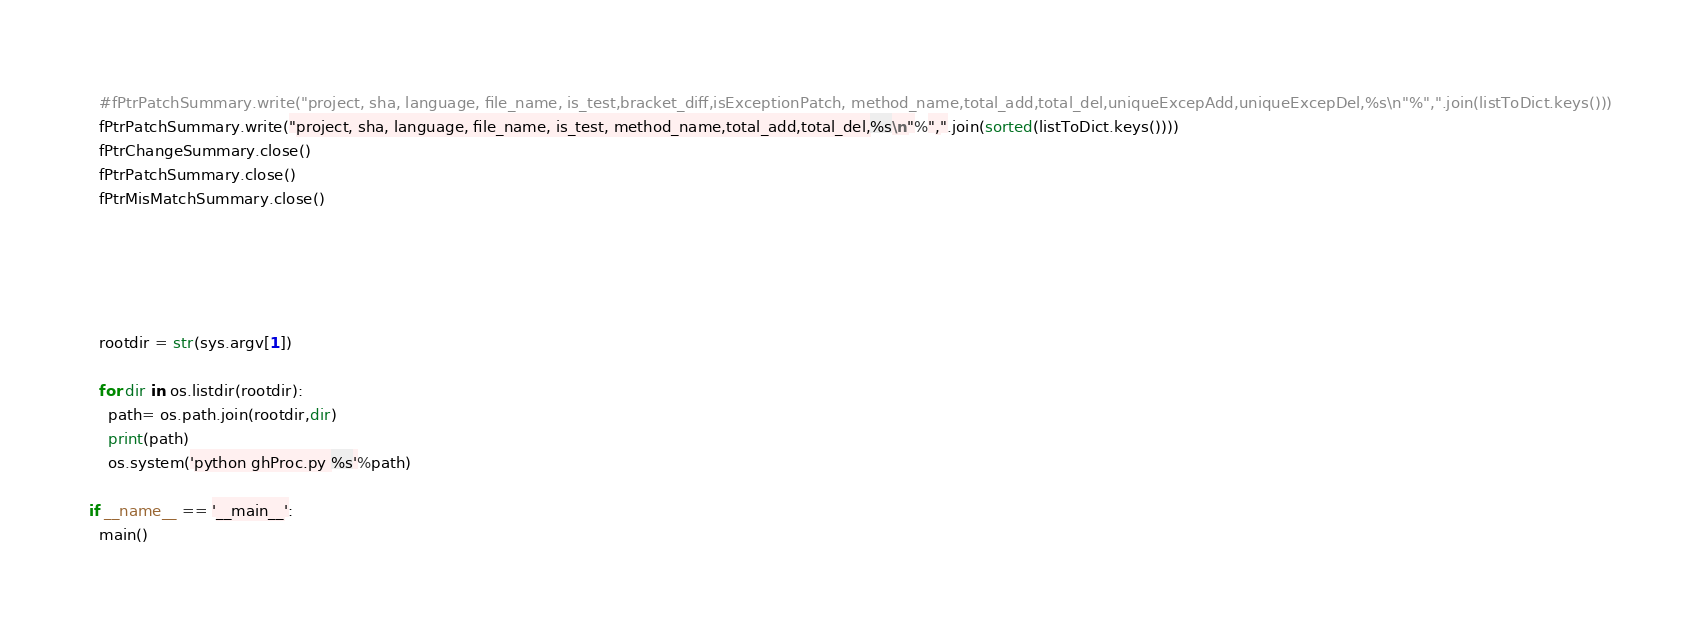<code> <loc_0><loc_0><loc_500><loc_500><_Python_>  #fPtrPatchSummary.write("project, sha, language, file_name, is_test,bracket_diff,isExceptionPatch, method_name,total_add,total_del,uniqueExcepAdd,uniqueExcepDel,%s\n"%",".join(listToDict.keys()))
  fPtrPatchSummary.write("project, sha, language, file_name, is_test, method_name,total_add,total_del,%s\n"%",".join(sorted(listToDict.keys())))
  fPtrChangeSummary.close()
  fPtrPatchSummary.close()
  fPtrMisMatchSummary.close()





  rootdir = str(sys.argv[1])

  for dir in os.listdir(rootdir):
    path= os.path.join(rootdir,dir)
    print(path)
    os.system('python ghProc.py %s'%path)

if __name__ == '__main__':
  main()
</code> 